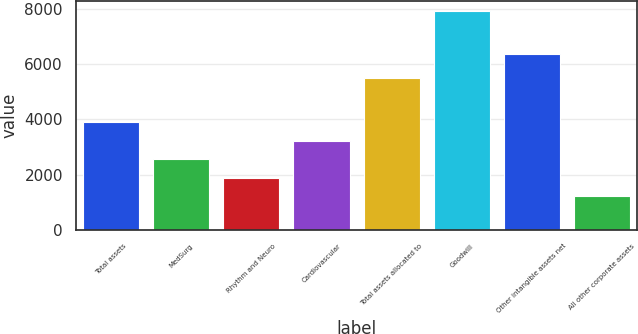Convert chart to OTSL. <chart><loc_0><loc_0><loc_500><loc_500><bar_chart><fcel>Total assets<fcel>MedSurg<fcel>Rhythm and Neuro<fcel>Cardiovascular<fcel>Total assets allocated to<fcel>Goodwill<fcel>Other intangible assets net<fcel>All other corporate assets<nl><fcel>3895.8<fcel>2557.4<fcel>1888.2<fcel>3226.6<fcel>5497<fcel>7911<fcel>6372<fcel>1219<nl></chart> 